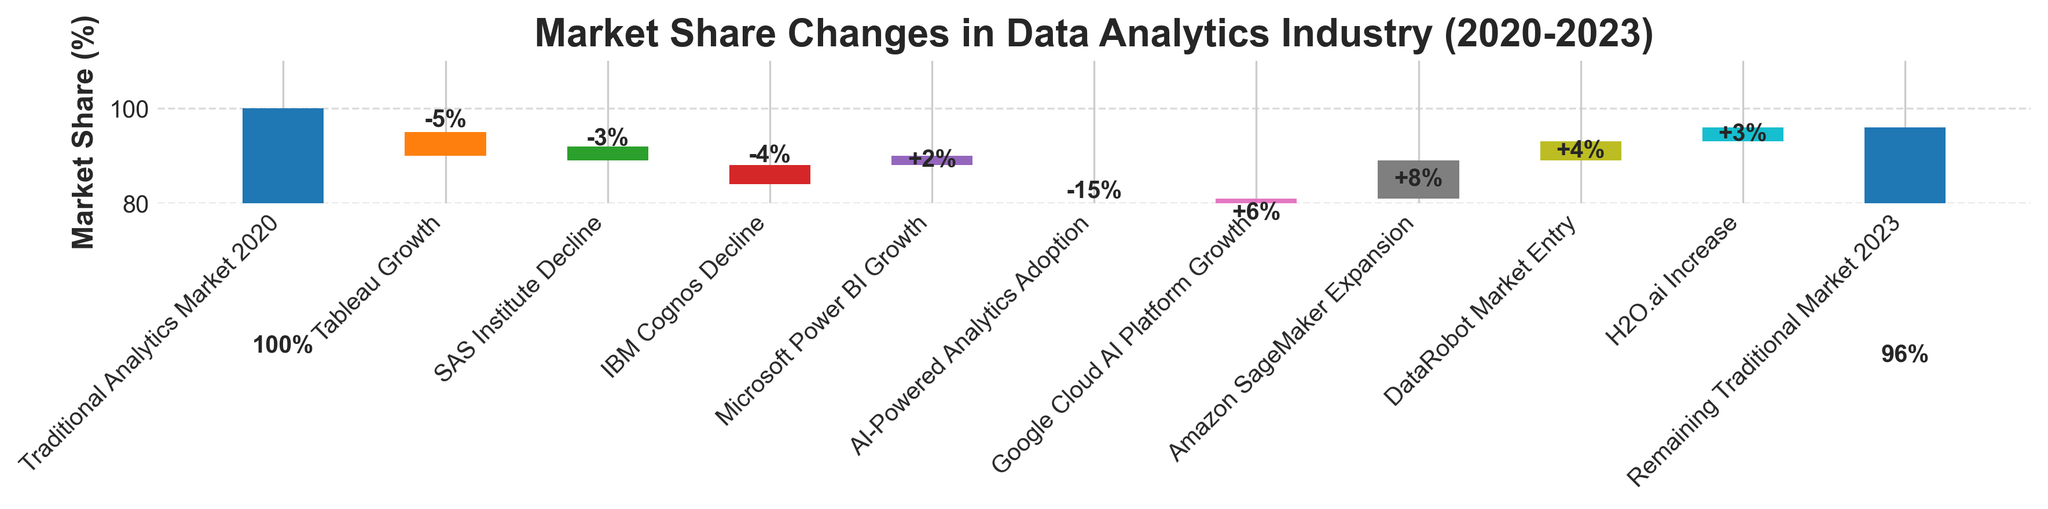What's the title of the chart? The title is typically located at the top of the chart, and it provides a concise summary of what the chart represents. In this case, the title directly states the focus of the data being shown.
Answer: Market Share Changes in Data Analytics Industry (2020-2023) How much market share did Google Cloud AI Platform gain? To find this, locate the segment labeled "Google Cloud AI Platform Growth" on the chart and note the value associated with it.
Answer: 6% What was the initial market share for traditional analytics in 2020? The initial market share is the starting point of the waterfall chart, usually represented by the first bar.
Answer: 100% How did traditional analytics market share change by 2023? To identify this, look at the final value on the waterfall chart labeled "Remaining Traditional Market 2023".
Answer: 96% What is the total decline in market share from SAS Institute and IBM Cognos? To find this, add up the individual declines from "SAS Institute Decline" and "IBM Cognos Decline". The values are -3 and -4, respectively.
Answer: -7% Which category saw the largest growth in market share? By observing the bars representing growth, identify the one with the highest positive value.
Answer: Amazon SageMaker Expansion What's the overall impact of AI-powered analytics adoption on traditional solutions? Summarize the effect shown in the "AI-Powered Analytics Adoption" value, which directly indicates how AI tools have affected market share.
Answer: -15% How does the market share loss from Tableau compare to the market share gain from Microsoft Power BI? To compare these, look at the values associated with both. Tableau has -5 and Microsoft Power BI has +2.
Answer: Tableau: -5%, Microsoft Power BI: +2% What's the total gain in market share from Google Cloud AI Platform, Amazon SageMaker, DataRobot, and H2O.ai combined? Add up the market share contributions from these categories: 6 (Google Cloud AI Platform) + 8 (Amazon SageMaker) + 4 (DataRobot) + 3 (H2O.ai) = 21%.
Answer: 21% How does the remaining traditional market share in 2023 compare to the initial market share in 2020? Compare the first and last data points in the chart. The initial market share was 100%, and the remaining market share in 2023 is 96%.
Answer: Initial: 100%, Remaining: 96% 